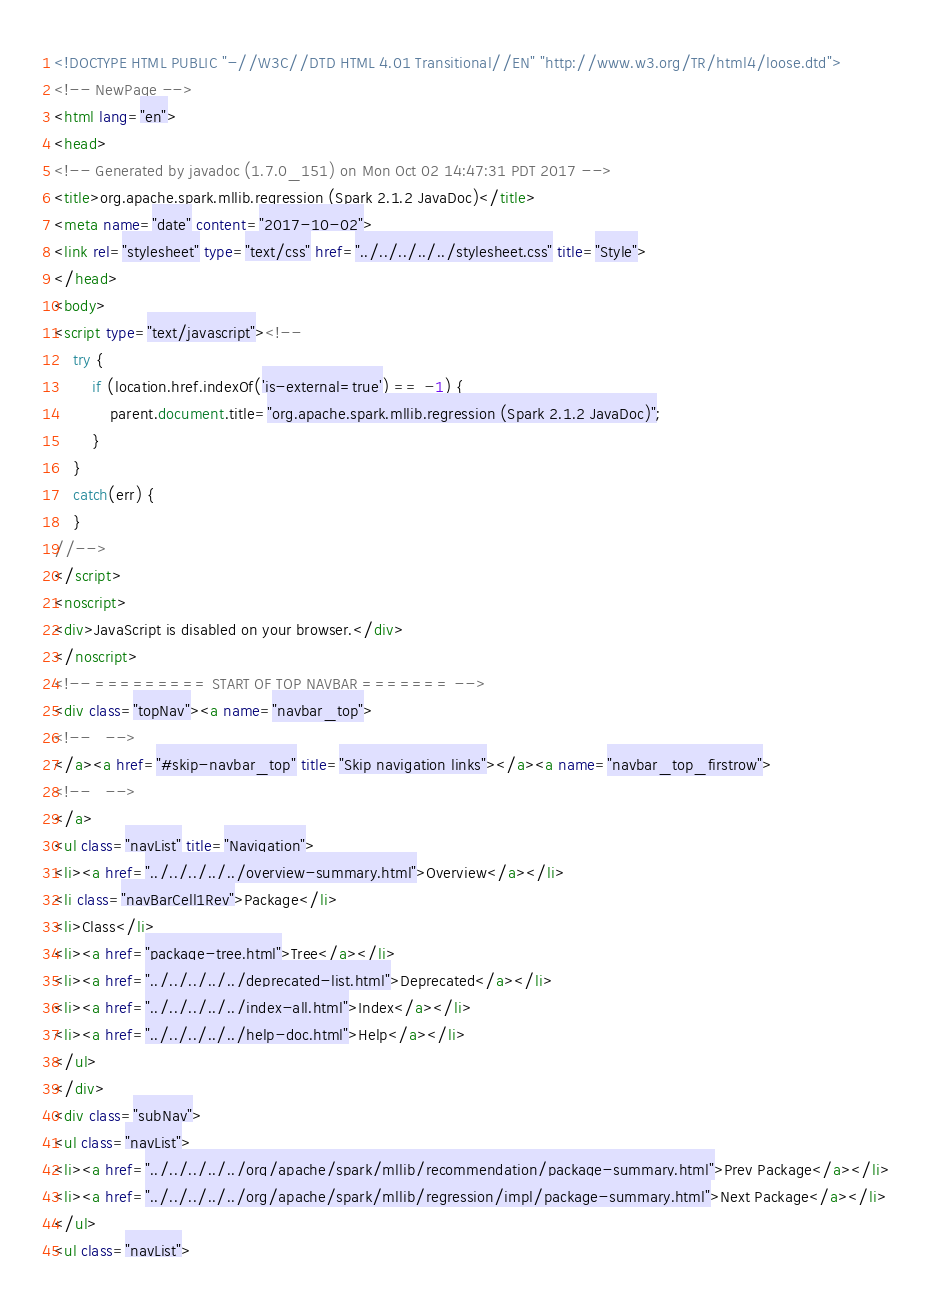<code> <loc_0><loc_0><loc_500><loc_500><_HTML_><!DOCTYPE HTML PUBLIC "-//W3C//DTD HTML 4.01 Transitional//EN" "http://www.w3.org/TR/html4/loose.dtd">
<!-- NewPage -->
<html lang="en">
<head>
<!-- Generated by javadoc (1.7.0_151) on Mon Oct 02 14:47:31 PDT 2017 -->
<title>org.apache.spark.mllib.regression (Spark 2.1.2 JavaDoc)</title>
<meta name="date" content="2017-10-02">
<link rel="stylesheet" type="text/css" href="../../../../../stylesheet.css" title="Style">
</head>
<body>
<script type="text/javascript"><!--
    try {
        if (location.href.indexOf('is-external=true') == -1) {
            parent.document.title="org.apache.spark.mllib.regression (Spark 2.1.2 JavaDoc)";
        }
    }
    catch(err) {
    }
//-->
</script>
<noscript>
<div>JavaScript is disabled on your browser.</div>
</noscript>
<!-- ========= START OF TOP NAVBAR ======= -->
<div class="topNav"><a name="navbar_top">
<!--   -->
</a><a href="#skip-navbar_top" title="Skip navigation links"></a><a name="navbar_top_firstrow">
<!--   -->
</a>
<ul class="navList" title="Navigation">
<li><a href="../../../../../overview-summary.html">Overview</a></li>
<li class="navBarCell1Rev">Package</li>
<li>Class</li>
<li><a href="package-tree.html">Tree</a></li>
<li><a href="../../../../../deprecated-list.html">Deprecated</a></li>
<li><a href="../../../../../index-all.html">Index</a></li>
<li><a href="../../../../../help-doc.html">Help</a></li>
</ul>
</div>
<div class="subNav">
<ul class="navList">
<li><a href="../../../../../org/apache/spark/mllib/recommendation/package-summary.html">Prev Package</a></li>
<li><a href="../../../../../org/apache/spark/mllib/regression/impl/package-summary.html">Next Package</a></li>
</ul>
<ul class="navList"></code> 